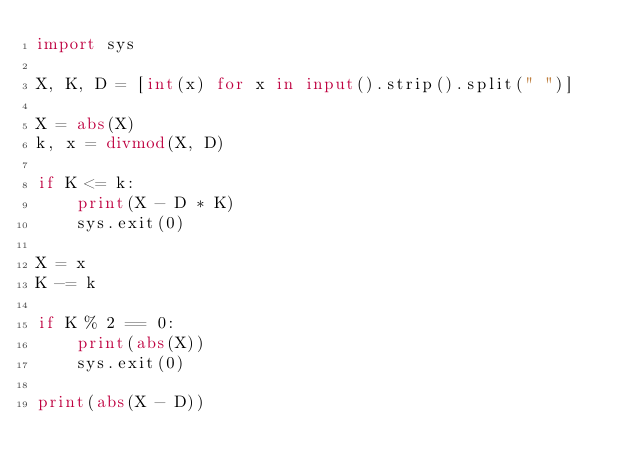Convert code to text. <code><loc_0><loc_0><loc_500><loc_500><_Python_>import sys

X, K, D = [int(x) for x in input().strip().split(" ")]

X = abs(X)
k, x = divmod(X, D)

if K <= k:
    print(X - D * K)
    sys.exit(0)

X = x
K -= k

if K % 2 == 0:
    print(abs(X))
    sys.exit(0)

print(abs(X - D))</code> 